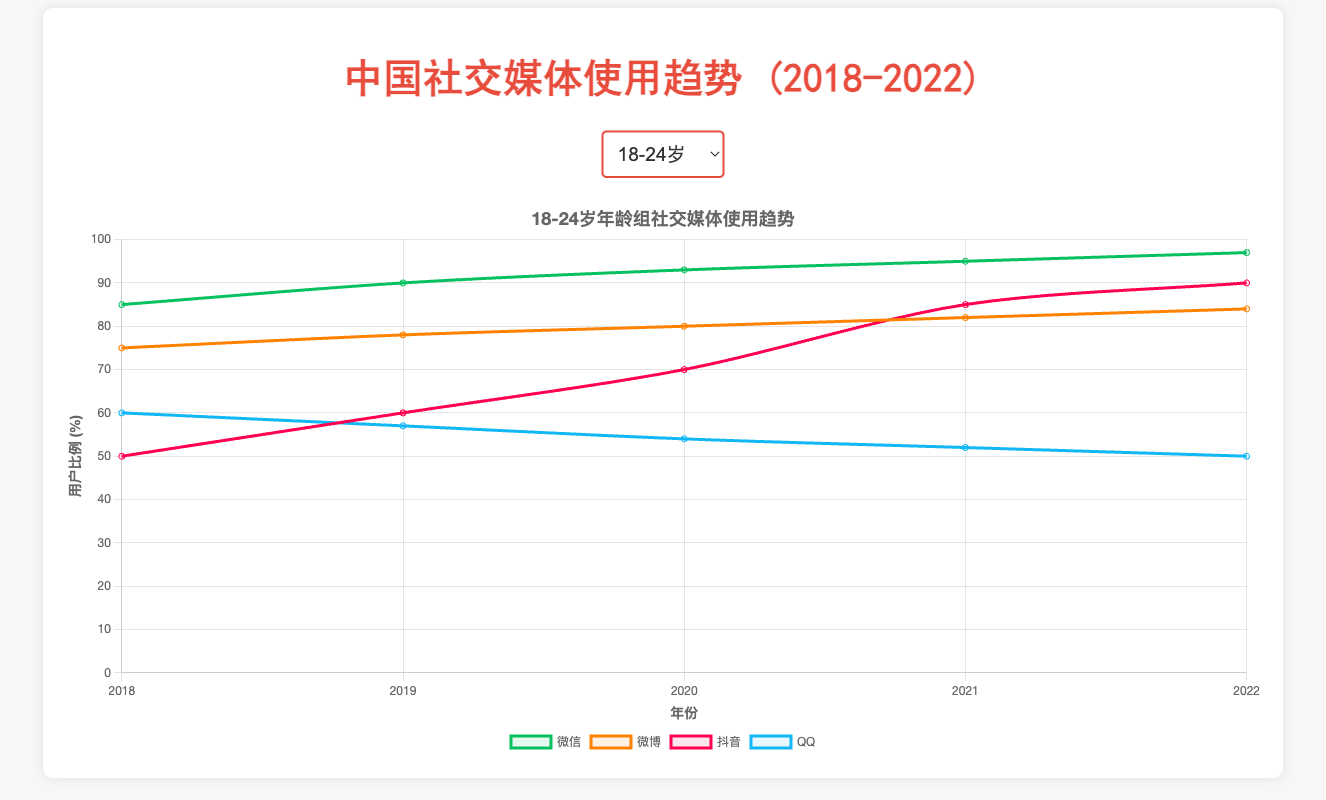What is the trend in Douyin usage among the 18-24 age group from 2018 to 2022? The percentage of Douyin users in the 18-24 age group increases consistently from 50% in 2018 to 90% in 2022.
Answer: Consistent increase Which age group showed the highest increase in WeChat usage from 2018 to 2022? The 55+ age group showed the highest increase, going from 50% in 2018 to 70% in 2022, an increase of 20%.
Answer: 55+ From 2018 to 2022, which social media platform had a decreasing trend in the 25-34 age group? QQ usage decreased from 55% in 2018 to 45% in 2022 in the 25-34 age group.
Answer: QQ Compare the Weibo usage in 2020 and 2021 for the 35-44 age group. Which year had a higher percentage and by how much? In 2020, Weibo usage was at 45%, while in 2021 it was 47%. 2021 had a higher percentage by 2%.
Answer: 2021, by 2% Which platform had the lowest percentage of users in the 45-54 age group in 2018? In 2018, the lowest percentage of users in the 45-54 age group was on Douyin, with only 15%.
Answer: Douyin What is the difference between WeChat usage and QQ usage in the 35-44 age group in 2022? In 2022, WeChat usage was 95%, and QQ usage was 32%. The difference is 95% - 32% = 63%.
Answer: 63% Is the trend in WeChat usage for the 18-24 age group linear or nonlinear? The trend in WeChat usage for the 18-24 age group appears to be nonlinear as it gradually increases from 85% to 97% over the years.
Answer: Nonlinear What is the average percentage of Douyin users in the 25-34 age group over the five years? Douyin usage in the 25-34 age group over the five years is 45%, 55%, 65%, 78%, 85%. Sum them: 45 + 55 + 65 + 78 + 85 = 328. The average is 328/5 = 65.6%.
Answer: 65.6% How did QQ usage change in the 45-54 age group from 2019 to 2021? QQ usage in the 45-54 age group decreased from 18% in 2019 to 14% in 2021, a decline of 4%.
Answer: Declined by 4% Which social media platform had the highest usage among the 25-34 age group in 2020, and what was the percentage? In 2020, WeChat had the highest usage in the 25-34 age group at 94%.
Answer: WeChat, 94% 